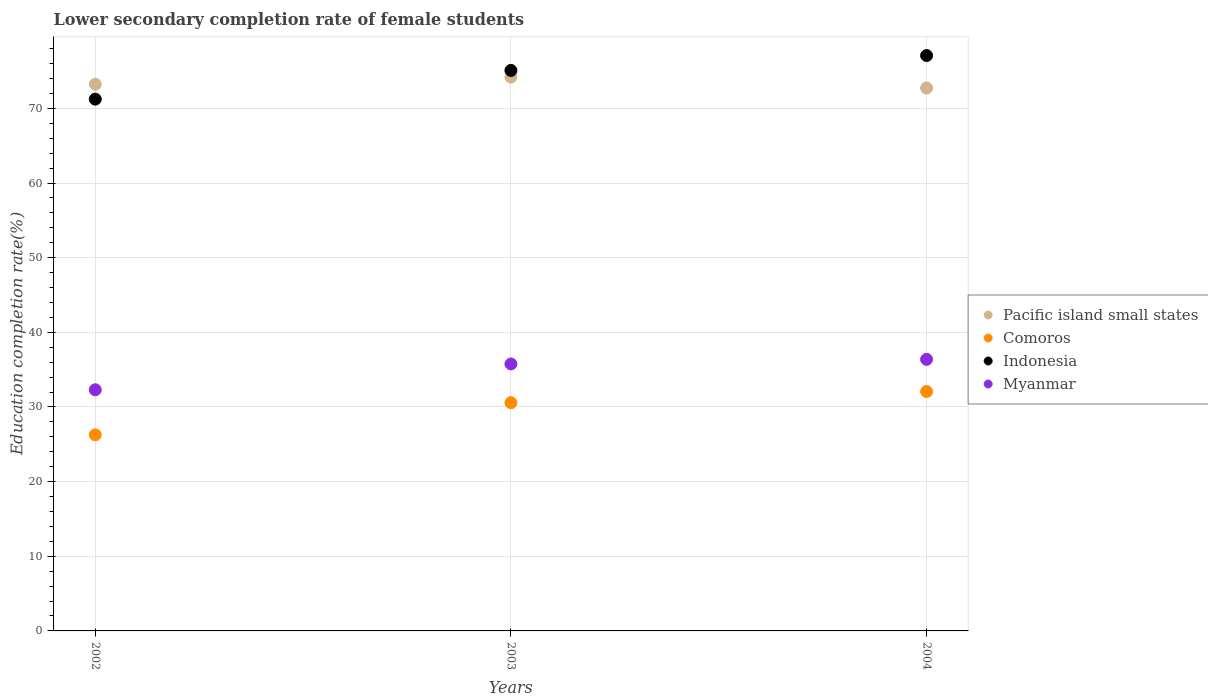How many different coloured dotlines are there?
Provide a succinct answer. 4. What is the lower secondary completion rate of female students in Pacific island small states in 2002?
Your answer should be very brief. 73.24. Across all years, what is the maximum lower secondary completion rate of female students in Pacific island small states?
Make the answer very short. 74.19. Across all years, what is the minimum lower secondary completion rate of female students in Indonesia?
Give a very brief answer. 71.24. In which year was the lower secondary completion rate of female students in Comoros maximum?
Your response must be concise. 2004. In which year was the lower secondary completion rate of female students in Indonesia minimum?
Your answer should be very brief. 2002. What is the total lower secondary completion rate of female students in Comoros in the graph?
Make the answer very short. 88.91. What is the difference between the lower secondary completion rate of female students in Myanmar in 2002 and that in 2004?
Your answer should be compact. -4.07. What is the difference between the lower secondary completion rate of female students in Indonesia in 2002 and the lower secondary completion rate of female students in Comoros in 2003?
Your answer should be very brief. 40.66. What is the average lower secondary completion rate of female students in Pacific island small states per year?
Make the answer very short. 73.38. In the year 2003, what is the difference between the lower secondary completion rate of female students in Myanmar and lower secondary completion rate of female students in Indonesia?
Give a very brief answer. -39.32. What is the ratio of the lower secondary completion rate of female students in Myanmar in 2002 to that in 2004?
Your response must be concise. 0.89. Is the difference between the lower secondary completion rate of female students in Myanmar in 2002 and 2003 greater than the difference between the lower secondary completion rate of female students in Indonesia in 2002 and 2003?
Your answer should be compact. Yes. What is the difference between the highest and the second highest lower secondary completion rate of female students in Comoros?
Give a very brief answer. 1.49. What is the difference between the highest and the lowest lower secondary completion rate of female students in Indonesia?
Keep it short and to the point. 5.84. In how many years, is the lower secondary completion rate of female students in Myanmar greater than the average lower secondary completion rate of female students in Myanmar taken over all years?
Provide a short and direct response. 2. Is it the case that in every year, the sum of the lower secondary completion rate of female students in Comoros and lower secondary completion rate of female students in Myanmar  is greater than the lower secondary completion rate of female students in Pacific island small states?
Keep it short and to the point. No. Does the lower secondary completion rate of female students in Comoros monotonically increase over the years?
Offer a terse response. Yes. Is the lower secondary completion rate of female students in Myanmar strictly greater than the lower secondary completion rate of female students in Comoros over the years?
Give a very brief answer. Yes. How many years are there in the graph?
Provide a succinct answer. 3. What is the difference between two consecutive major ticks on the Y-axis?
Your answer should be very brief. 10. Are the values on the major ticks of Y-axis written in scientific E-notation?
Keep it short and to the point. No. Does the graph contain grids?
Provide a short and direct response. Yes. Where does the legend appear in the graph?
Provide a short and direct response. Center right. How many legend labels are there?
Your answer should be very brief. 4. How are the legend labels stacked?
Your answer should be compact. Vertical. What is the title of the graph?
Ensure brevity in your answer.  Lower secondary completion rate of female students. What is the label or title of the X-axis?
Make the answer very short. Years. What is the label or title of the Y-axis?
Give a very brief answer. Education completion rate(%). What is the Education completion rate(%) of Pacific island small states in 2002?
Make the answer very short. 73.24. What is the Education completion rate(%) of Comoros in 2002?
Give a very brief answer. 26.27. What is the Education completion rate(%) of Indonesia in 2002?
Your answer should be very brief. 71.24. What is the Education completion rate(%) in Myanmar in 2002?
Your answer should be very brief. 32.3. What is the Education completion rate(%) of Pacific island small states in 2003?
Your response must be concise. 74.19. What is the Education completion rate(%) of Comoros in 2003?
Your answer should be compact. 30.57. What is the Education completion rate(%) of Indonesia in 2003?
Provide a short and direct response. 75.08. What is the Education completion rate(%) in Myanmar in 2003?
Your answer should be very brief. 35.76. What is the Education completion rate(%) in Pacific island small states in 2004?
Ensure brevity in your answer.  72.73. What is the Education completion rate(%) of Comoros in 2004?
Provide a short and direct response. 32.07. What is the Education completion rate(%) in Indonesia in 2004?
Provide a succinct answer. 77.08. What is the Education completion rate(%) in Myanmar in 2004?
Provide a short and direct response. 36.38. Across all years, what is the maximum Education completion rate(%) in Pacific island small states?
Offer a very short reply. 74.19. Across all years, what is the maximum Education completion rate(%) of Comoros?
Your response must be concise. 32.07. Across all years, what is the maximum Education completion rate(%) in Indonesia?
Offer a very short reply. 77.08. Across all years, what is the maximum Education completion rate(%) in Myanmar?
Your answer should be compact. 36.38. Across all years, what is the minimum Education completion rate(%) in Pacific island small states?
Offer a terse response. 72.73. Across all years, what is the minimum Education completion rate(%) in Comoros?
Offer a very short reply. 26.27. Across all years, what is the minimum Education completion rate(%) in Indonesia?
Your answer should be very brief. 71.24. Across all years, what is the minimum Education completion rate(%) of Myanmar?
Give a very brief answer. 32.3. What is the total Education completion rate(%) in Pacific island small states in the graph?
Your answer should be compact. 220.15. What is the total Education completion rate(%) in Comoros in the graph?
Provide a short and direct response. 88.91. What is the total Education completion rate(%) of Indonesia in the graph?
Your answer should be very brief. 223.39. What is the total Education completion rate(%) of Myanmar in the graph?
Keep it short and to the point. 104.44. What is the difference between the Education completion rate(%) in Pacific island small states in 2002 and that in 2003?
Make the answer very short. -0.95. What is the difference between the Education completion rate(%) in Comoros in 2002 and that in 2003?
Keep it short and to the point. -4.31. What is the difference between the Education completion rate(%) in Indonesia in 2002 and that in 2003?
Give a very brief answer. -3.85. What is the difference between the Education completion rate(%) of Myanmar in 2002 and that in 2003?
Offer a terse response. -3.46. What is the difference between the Education completion rate(%) of Pacific island small states in 2002 and that in 2004?
Offer a terse response. 0.51. What is the difference between the Education completion rate(%) of Comoros in 2002 and that in 2004?
Give a very brief answer. -5.8. What is the difference between the Education completion rate(%) in Indonesia in 2002 and that in 2004?
Your answer should be very brief. -5.84. What is the difference between the Education completion rate(%) in Myanmar in 2002 and that in 2004?
Ensure brevity in your answer.  -4.07. What is the difference between the Education completion rate(%) in Pacific island small states in 2003 and that in 2004?
Give a very brief answer. 1.46. What is the difference between the Education completion rate(%) in Comoros in 2003 and that in 2004?
Give a very brief answer. -1.49. What is the difference between the Education completion rate(%) of Indonesia in 2003 and that in 2004?
Make the answer very short. -2. What is the difference between the Education completion rate(%) in Myanmar in 2003 and that in 2004?
Keep it short and to the point. -0.61. What is the difference between the Education completion rate(%) in Pacific island small states in 2002 and the Education completion rate(%) in Comoros in 2003?
Provide a short and direct response. 42.66. What is the difference between the Education completion rate(%) of Pacific island small states in 2002 and the Education completion rate(%) of Indonesia in 2003?
Give a very brief answer. -1.85. What is the difference between the Education completion rate(%) of Pacific island small states in 2002 and the Education completion rate(%) of Myanmar in 2003?
Offer a terse response. 37.47. What is the difference between the Education completion rate(%) of Comoros in 2002 and the Education completion rate(%) of Indonesia in 2003?
Offer a very short reply. -48.82. What is the difference between the Education completion rate(%) of Comoros in 2002 and the Education completion rate(%) of Myanmar in 2003?
Offer a terse response. -9.5. What is the difference between the Education completion rate(%) of Indonesia in 2002 and the Education completion rate(%) of Myanmar in 2003?
Provide a succinct answer. 35.47. What is the difference between the Education completion rate(%) in Pacific island small states in 2002 and the Education completion rate(%) in Comoros in 2004?
Provide a short and direct response. 41.17. What is the difference between the Education completion rate(%) of Pacific island small states in 2002 and the Education completion rate(%) of Indonesia in 2004?
Keep it short and to the point. -3.84. What is the difference between the Education completion rate(%) of Pacific island small states in 2002 and the Education completion rate(%) of Myanmar in 2004?
Your response must be concise. 36.86. What is the difference between the Education completion rate(%) of Comoros in 2002 and the Education completion rate(%) of Indonesia in 2004?
Provide a succinct answer. -50.81. What is the difference between the Education completion rate(%) of Comoros in 2002 and the Education completion rate(%) of Myanmar in 2004?
Ensure brevity in your answer.  -10.11. What is the difference between the Education completion rate(%) in Indonesia in 2002 and the Education completion rate(%) in Myanmar in 2004?
Offer a terse response. 34.86. What is the difference between the Education completion rate(%) of Pacific island small states in 2003 and the Education completion rate(%) of Comoros in 2004?
Provide a short and direct response. 42.12. What is the difference between the Education completion rate(%) of Pacific island small states in 2003 and the Education completion rate(%) of Indonesia in 2004?
Offer a terse response. -2.89. What is the difference between the Education completion rate(%) of Pacific island small states in 2003 and the Education completion rate(%) of Myanmar in 2004?
Keep it short and to the point. 37.81. What is the difference between the Education completion rate(%) of Comoros in 2003 and the Education completion rate(%) of Indonesia in 2004?
Provide a succinct answer. -46.5. What is the difference between the Education completion rate(%) of Comoros in 2003 and the Education completion rate(%) of Myanmar in 2004?
Your response must be concise. -5.8. What is the difference between the Education completion rate(%) of Indonesia in 2003 and the Education completion rate(%) of Myanmar in 2004?
Your response must be concise. 38.7. What is the average Education completion rate(%) in Pacific island small states per year?
Give a very brief answer. 73.38. What is the average Education completion rate(%) in Comoros per year?
Keep it short and to the point. 29.64. What is the average Education completion rate(%) of Indonesia per year?
Keep it short and to the point. 74.46. What is the average Education completion rate(%) in Myanmar per year?
Your answer should be very brief. 34.81. In the year 2002, what is the difference between the Education completion rate(%) in Pacific island small states and Education completion rate(%) in Comoros?
Your answer should be compact. 46.97. In the year 2002, what is the difference between the Education completion rate(%) of Pacific island small states and Education completion rate(%) of Indonesia?
Offer a very short reply. 2. In the year 2002, what is the difference between the Education completion rate(%) in Pacific island small states and Education completion rate(%) in Myanmar?
Make the answer very short. 40.93. In the year 2002, what is the difference between the Education completion rate(%) of Comoros and Education completion rate(%) of Indonesia?
Make the answer very short. -44.97. In the year 2002, what is the difference between the Education completion rate(%) in Comoros and Education completion rate(%) in Myanmar?
Offer a very short reply. -6.04. In the year 2002, what is the difference between the Education completion rate(%) in Indonesia and Education completion rate(%) in Myanmar?
Provide a succinct answer. 38.93. In the year 2003, what is the difference between the Education completion rate(%) of Pacific island small states and Education completion rate(%) of Comoros?
Keep it short and to the point. 43.61. In the year 2003, what is the difference between the Education completion rate(%) in Pacific island small states and Education completion rate(%) in Indonesia?
Your response must be concise. -0.9. In the year 2003, what is the difference between the Education completion rate(%) of Pacific island small states and Education completion rate(%) of Myanmar?
Make the answer very short. 38.42. In the year 2003, what is the difference between the Education completion rate(%) of Comoros and Education completion rate(%) of Indonesia?
Make the answer very short. -44.51. In the year 2003, what is the difference between the Education completion rate(%) in Comoros and Education completion rate(%) in Myanmar?
Offer a terse response. -5.19. In the year 2003, what is the difference between the Education completion rate(%) of Indonesia and Education completion rate(%) of Myanmar?
Provide a short and direct response. 39.32. In the year 2004, what is the difference between the Education completion rate(%) in Pacific island small states and Education completion rate(%) in Comoros?
Your answer should be very brief. 40.66. In the year 2004, what is the difference between the Education completion rate(%) in Pacific island small states and Education completion rate(%) in Indonesia?
Offer a terse response. -4.35. In the year 2004, what is the difference between the Education completion rate(%) of Pacific island small states and Education completion rate(%) of Myanmar?
Offer a very short reply. 36.35. In the year 2004, what is the difference between the Education completion rate(%) in Comoros and Education completion rate(%) in Indonesia?
Ensure brevity in your answer.  -45.01. In the year 2004, what is the difference between the Education completion rate(%) in Comoros and Education completion rate(%) in Myanmar?
Give a very brief answer. -4.31. In the year 2004, what is the difference between the Education completion rate(%) of Indonesia and Education completion rate(%) of Myanmar?
Make the answer very short. 40.7. What is the ratio of the Education completion rate(%) of Pacific island small states in 2002 to that in 2003?
Your response must be concise. 0.99. What is the ratio of the Education completion rate(%) in Comoros in 2002 to that in 2003?
Your response must be concise. 0.86. What is the ratio of the Education completion rate(%) in Indonesia in 2002 to that in 2003?
Offer a very short reply. 0.95. What is the ratio of the Education completion rate(%) in Myanmar in 2002 to that in 2003?
Offer a very short reply. 0.9. What is the ratio of the Education completion rate(%) of Pacific island small states in 2002 to that in 2004?
Give a very brief answer. 1.01. What is the ratio of the Education completion rate(%) of Comoros in 2002 to that in 2004?
Make the answer very short. 0.82. What is the ratio of the Education completion rate(%) of Indonesia in 2002 to that in 2004?
Provide a succinct answer. 0.92. What is the ratio of the Education completion rate(%) of Myanmar in 2002 to that in 2004?
Your answer should be compact. 0.89. What is the ratio of the Education completion rate(%) in Pacific island small states in 2003 to that in 2004?
Your response must be concise. 1.02. What is the ratio of the Education completion rate(%) in Comoros in 2003 to that in 2004?
Provide a short and direct response. 0.95. What is the ratio of the Education completion rate(%) of Indonesia in 2003 to that in 2004?
Provide a short and direct response. 0.97. What is the ratio of the Education completion rate(%) of Myanmar in 2003 to that in 2004?
Offer a terse response. 0.98. What is the difference between the highest and the second highest Education completion rate(%) of Pacific island small states?
Provide a succinct answer. 0.95. What is the difference between the highest and the second highest Education completion rate(%) of Comoros?
Make the answer very short. 1.49. What is the difference between the highest and the second highest Education completion rate(%) of Indonesia?
Provide a short and direct response. 2. What is the difference between the highest and the second highest Education completion rate(%) in Myanmar?
Provide a succinct answer. 0.61. What is the difference between the highest and the lowest Education completion rate(%) in Pacific island small states?
Your answer should be compact. 1.46. What is the difference between the highest and the lowest Education completion rate(%) of Comoros?
Make the answer very short. 5.8. What is the difference between the highest and the lowest Education completion rate(%) in Indonesia?
Your answer should be very brief. 5.84. What is the difference between the highest and the lowest Education completion rate(%) in Myanmar?
Your answer should be very brief. 4.07. 